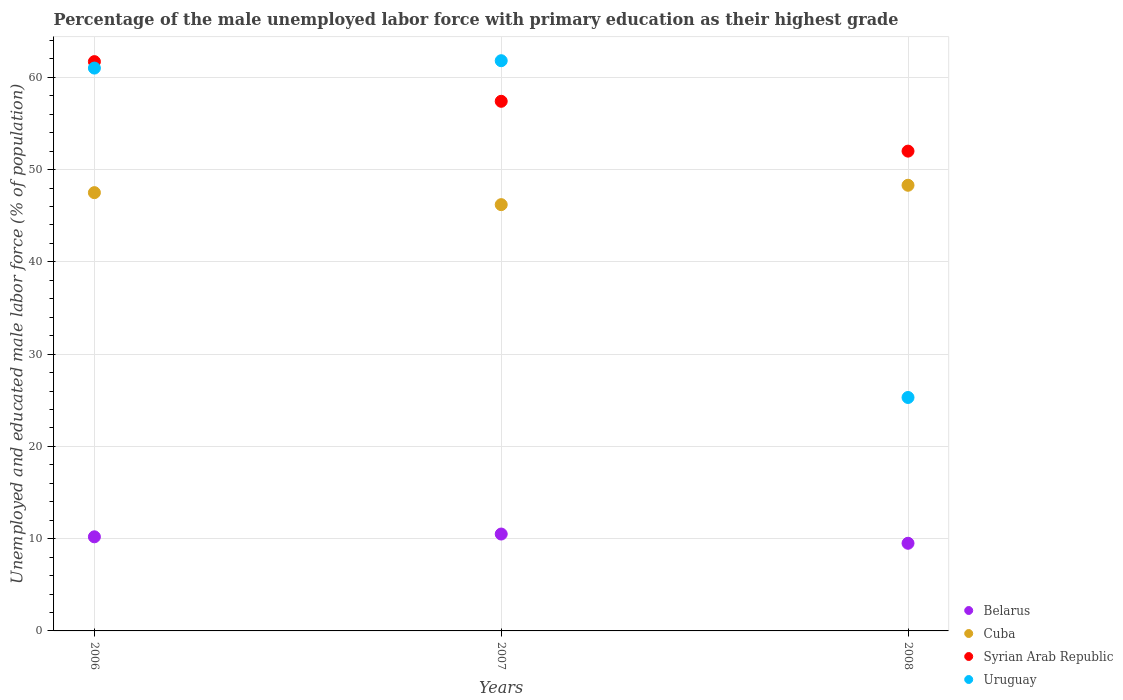How many different coloured dotlines are there?
Offer a terse response. 4. Is the number of dotlines equal to the number of legend labels?
Offer a terse response. Yes. What is the percentage of the unemployed male labor force with primary education in Cuba in 2008?
Keep it short and to the point. 48.3. Across all years, what is the maximum percentage of the unemployed male labor force with primary education in Belarus?
Make the answer very short. 10.5. Across all years, what is the minimum percentage of the unemployed male labor force with primary education in Cuba?
Offer a very short reply. 46.2. In which year was the percentage of the unemployed male labor force with primary education in Uruguay minimum?
Your response must be concise. 2008. What is the total percentage of the unemployed male labor force with primary education in Uruguay in the graph?
Offer a very short reply. 148.1. What is the difference between the percentage of the unemployed male labor force with primary education in Cuba in 2007 and that in 2008?
Make the answer very short. -2.1. What is the difference between the percentage of the unemployed male labor force with primary education in Cuba in 2008 and the percentage of the unemployed male labor force with primary education in Syrian Arab Republic in 2007?
Provide a succinct answer. -9.1. What is the average percentage of the unemployed male labor force with primary education in Belarus per year?
Offer a terse response. 10.07. In the year 2008, what is the difference between the percentage of the unemployed male labor force with primary education in Cuba and percentage of the unemployed male labor force with primary education in Uruguay?
Make the answer very short. 23. In how many years, is the percentage of the unemployed male labor force with primary education in Uruguay greater than 60 %?
Your answer should be compact. 2. What is the ratio of the percentage of the unemployed male labor force with primary education in Belarus in 2006 to that in 2008?
Your answer should be compact. 1.07. What is the difference between the highest and the second highest percentage of the unemployed male labor force with primary education in Uruguay?
Make the answer very short. 0.8. What is the difference between the highest and the lowest percentage of the unemployed male labor force with primary education in Cuba?
Your response must be concise. 2.1. In how many years, is the percentage of the unemployed male labor force with primary education in Belarus greater than the average percentage of the unemployed male labor force with primary education in Belarus taken over all years?
Provide a succinct answer. 2. Is the sum of the percentage of the unemployed male labor force with primary education in Belarus in 2006 and 2007 greater than the maximum percentage of the unemployed male labor force with primary education in Cuba across all years?
Keep it short and to the point. No. Does the percentage of the unemployed male labor force with primary education in Belarus monotonically increase over the years?
Ensure brevity in your answer.  No. Is the percentage of the unemployed male labor force with primary education in Uruguay strictly greater than the percentage of the unemployed male labor force with primary education in Cuba over the years?
Your answer should be compact. No. Is the percentage of the unemployed male labor force with primary education in Syrian Arab Republic strictly less than the percentage of the unemployed male labor force with primary education in Belarus over the years?
Give a very brief answer. No. How many dotlines are there?
Make the answer very short. 4. What is the difference between two consecutive major ticks on the Y-axis?
Make the answer very short. 10. Are the values on the major ticks of Y-axis written in scientific E-notation?
Your response must be concise. No. Does the graph contain any zero values?
Provide a succinct answer. No. Does the graph contain grids?
Give a very brief answer. Yes. Where does the legend appear in the graph?
Give a very brief answer. Bottom right. How are the legend labels stacked?
Ensure brevity in your answer.  Vertical. What is the title of the graph?
Offer a terse response. Percentage of the male unemployed labor force with primary education as their highest grade. Does "Turkey" appear as one of the legend labels in the graph?
Keep it short and to the point. No. What is the label or title of the Y-axis?
Give a very brief answer. Unemployed and educated male labor force (% of population). What is the Unemployed and educated male labor force (% of population) of Belarus in 2006?
Offer a very short reply. 10.2. What is the Unemployed and educated male labor force (% of population) of Cuba in 2006?
Your answer should be compact. 47.5. What is the Unemployed and educated male labor force (% of population) of Syrian Arab Republic in 2006?
Make the answer very short. 61.7. What is the Unemployed and educated male labor force (% of population) of Belarus in 2007?
Give a very brief answer. 10.5. What is the Unemployed and educated male labor force (% of population) of Cuba in 2007?
Ensure brevity in your answer.  46.2. What is the Unemployed and educated male labor force (% of population) of Syrian Arab Republic in 2007?
Keep it short and to the point. 57.4. What is the Unemployed and educated male labor force (% of population) of Uruguay in 2007?
Keep it short and to the point. 61.8. What is the Unemployed and educated male labor force (% of population) in Belarus in 2008?
Keep it short and to the point. 9.5. What is the Unemployed and educated male labor force (% of population) in Cuba in 2008?
Your response must be concise. 48.3. What is the Unemployed and educated male labor force (% of population) in Uruguay in 2008?
Offer a very short reply. 25.3. Across all years, what is the maximum Unemployed and educated male labor force (% of population) of Belarus?
Your answer should be compact. 10.5. Across all years, what is the maximum Unemployed and educated male labor force (% of population) of Cuba?
Make the answer very short. 48.3. Across all years, what is the maximum Unemployed and educated male labor force (% of population) in Syrian Arab Republic?
Make the answer very short. 61.7. Across all years, what is the maximum Unemployed and educated male labor force (% of population) in Uruguay?
Keep it short and to the point. 61.8. Across all years, what is the minimum Unemployed and educated male labor force (% of population) of Cuba?
Your response must be concise. 46.2. Across all years, what is the minimum Unemployed and educated male labor force (% of population) in Uruguay?
Your response must be concise. 25.3. What is the total Unemployed and educated male labor force (% of population) in Belarus in the graph?
Provide a short and direct response. 30.2. What is the total Unemployed and educated male labor force (% of population) in Cuba in the graph?
Offer a terse response. 142. What is the total Unemployed and educated male labor force (% of population) of Syrian Arab Republic in the graph?
Offer a very short reply. 171.1. What is the total Unemployed and educated male labor force (% of population) in Uruguay in the graph?
Your answer should be very brief. 148.1. What is the difference between the Unemployed and educated male labor force (% of population) of Syrian Arab Republic in 2006 and that in 2007?
Your response must be concise. 4.3. What is the difference between the Unemployed and educated male labor force (% of population) in Cuba in 2006 and that in 2008?
Provide a succinct answer. -0.8. What is the difference between the Unemployed and educated male labor force (% of population) of Uruguay in 2006 and that in 2008?
Provide a short and direct response. 35.7. What is the difference between the Unemployed and educated male labor force (% of population) in Cuba in 2007 and that in 2008?
Give a very brief answer. -2.1. What is the difference between the Unemployed and educated male labor force (% of population) of Syrian Arab Republic in 2007 and that in 2008?
Ensure brevity in your answer.  5.4. What is the difference between the Unemployed and educated male labor force (% of population) in Uruguay in 2007 and that in 2008?
Provide a succinct answer. 36.5. What is the difference between the Unemployed and educated male labor force (% of population) in Belarus in 2006 and the Unemployed and educated male labor force (% of population) in Cuba in 2007?
Your response must be concise. -36. What is the difference between the Unemployed and educated male labor force (% of population) in Belarus in 2006 and the Unemployed and educated male labor force (% of population) in Syrian Arab Republic in 2007?
Offer a terse response. -47.2. What is the difference between the Unemployed and educated male labor force (% of population) of Belarus in 2006 and the Unemployed and educated male labor force (% of population) of Uruguay in 2007?
Offer a very short reply. -51.6. What is the difference between the Unemployed and educated male labor force (% of population) of Cuba in 2006 and the Unemployed and educated male labor force (% of population) of Syrian Arab Republic in 2007?
Offer a very short reply. -9.9. What is the difference between the Unemployed and educated male labor force (% of population) in Cuba in 2006 and the Unemployed and educated male labor force (% of population) in Uruguay in 2007?
Your response must be concise. -14.3. What is the difference between the Unemployed and educated male labor force (% of population) of Syrian Arab Republic in 2006 and the Unemployed and educated male labor force (% of population) of Uruguay in 2007?
Provide a short and direct response. -0.1. What is the difference between the Unemployed and educated male labor force (% of population) of Belarus in 2006 and the Unemployed and educated male labor force (% of population) of Cuba in 2008?
Provide a succinct answer. -38.1. What is the difference between the Unemployed and educated male labor force (% of population) of Belarus in 2006 and the Unemployed and educated male labor force (% of population) of Syrian Arab Republic in 2008?
Give a very brief answer. -41.8. What is the difference between the Unemployed and educated male labor force (% of population) of Belarus in 2006 and the Unemployed and educated male labor force (% of population) of Uruguay in 2008?
Ensure brevity in your answer.  -15.1. What is the difference between the Unemployed and educated male labor force (% of population) of Syrian Arab Republic in 2006 and the Unemployed and educated male labor force (% of population) of Uruguay in 2008?
Your response must be concise. 36.4. What is the difference between the Unemployed and educated male labor force (% of population) of Belarus in 2007 and the Unemployed and educated male labor force (% of population) of Cuba in 2008?
Offer a very short reply. -37.8. What is the difference between the Unemployed and educated male labor force (% of population) in Belarus in 2007 and the Unemployed and educated male labor force (% of population) in Syrian Arab Republic in 2008?
Your answer should be very brief. -41.5. What is the difference between the Unemployed and educated male labor force (% of population) in Belarus in 2007 and the Unemployed and educated male labor force (% of population) in Uruguay in 2008?
Your response must be concise. -14.8. What is the difference between the Unemployed and educated male labor force (% of population) in Cuba in 2007 and the Unemployed and educated male labor force (% of population) in Syrian Arab Republic in 2008?
Your answer should be very brief. -5.8. What is the difference between the Unemployed and educated male labor force (% of population) in Cuba in 2007 and the Unemployed and educated male labor force (% of population) in Uruguay in 2008?
Make the answer very short. 20.9. What is the difference between the Unemployed and educated male labor force (% of population) in Syrian Arab Republic in 2007 and the Unemployed and educated male labor force (% of population) in Uruguay in 2008?
Make the answer very short. 32.1. What is the average Unemployed and educated male labor force (% of population) in Belarus per year?
Give a very brief answer. 10.07. What is the average Unemployed and educated male labor force (% of population) of Cuba per year?
Your answer should be compact. 47.33. What is the average Unemployed and educated male labor force (% of population) in Syrian Arab Republic per year?
Make the answer very short. 57.03. What is the average Unemployed and educated male labor force (% of population) in Uruguay per year?
Ensure brevity in your answer.  49.37. In the year 2006, what is the difference between the Unemployed and educated male labor force (% of population) of Belarus and Unemployed and educated male labor force (% of population) of Cuba?
Give a very brief answer. -37.3. In the year 2006, what is the difference between the Unemployed and educated male labor force (% of population) in Belarus and Unemployed and educated male labor force (% of population) in Syrian Arab Republic?
Give a very brief answer. -51.5. In the year 2006, what is the difference between the Unemployed and educated male labor force (% of population) of Belarus and Unemployed and educated male labor force (% of population) of Uruguay?
Give a very brief answer. -50.8. In the year 2006, what is the difference between the Unemployed and educated male labor force (% of population) in Cuba and Unemployed and educated male labor force (% of population) in Uruguay?
Offer a very short reply. -13.5. In the year 2006, what is the difference between the Unemployed and educated male labor force (% of population) in Syrian Arab Republic and Unemployed and educated male labor force (% of population) in Uruguay?
Offer a very short reply. 0.7. In the year 2007, what is the difference between the Unemployed and educated male labor force (% of population) in Belarus and Unemployed and educated male labor force (% of population) in Cuba?
Provide a succinct answer. -35.7. In the year 2007, what is the difference between the Unemployed and educated male labor force (% of population) in Belarus and Unemployed and educated male labor force (% of population) in Syrian Arab Republic?
Offer a terse response. -46.9. In the year 2007, what is the difference between the Unemployed and educated male labor force (% of population) of Belarus and Unemployed and educated male labor force (% of population) of Uruguay?
Provide a short and direct response. -51.3. In the year 2007, what is the difference between the Unemployed and educated male labor force (% of population) in Cuba and Unemployed and educated male labor force (% of population) in Syrian Arab Republic?
Your answer should be compact. -11.2. In the year 2007, what is the difference between the Unemployed and educated male labor force (% of population) in Cuba and Unemployed and educated male labor force (% of population) in Uruguay?
Ensure brevity in your answer.  -15.6. In the year 2008, what is the difference between the Unemployed and educated male labor force (% of population) in Belarus and Unemployed and educated male labor force (% of population) in Cuba?
Give a very brief answer. -38.8. In the year 2008, what is the difference between the Unemployed and educated male labor force (% of population) in Belarus and Unemployed and educated male labor force (% of population) in Syrian Arab Republic?
Provide a short and direct response. -42.5. In the year 2008, what is the difference between the Unemployed and educated male labor force (% of population) of Belarus and Unemployed and educated male labor force (% of population) of Uruguay?
Offer a terse response. -15.8. In the year 2008, what is the difference between the Unemployed and educated male labor force (% of population) of Cuba and Unemployed and educated male labor force (% of population) of Syrian Arab Republic?
Your answer should be very brief. -3.7. In the year 2008, what is the difference between the Unemployed and educated male labor force (% of population) of Syrian Arab Republic and Unemployed and educated male labor force (% of population) of Uruguay?
Offer a terse response. 26.7. What is the ratio of the Unemployed and educated male labor force (% of population) of Belarus in 2006 to that in 2007?
Your answer should be compact. 0.97. What is the ratio of the Unemployed and educated male labor force (% of population) in Cuba in 2006 to that in 2007?
Make the answer very short. 1.03. What is the ratio of the Unemployed and educated male labor force (% of population) in Syrian Arab Republic in 2006 to that in 2007?
Offer a very short reply. 1.07. What is the ratio of the Unemployed and educated male labor force (% of population) of Uruguay in 2006 to that in 2007?
Provide a succinct answer. 0.99. What is the ratio of the Unemployed and educated male labor force (% of population) in Belarus in 2006 to that in 2008?
Your answer should be compact. 1.07. What is the ratio of the Unemployed and educated male labor force (% of population) of Cuba in 2006 to that in 2008?
Your answer should be very brief. 0.98. What is the ratio of the Unemployed and educated male labor force (% of population) in Syrian Arab Republic in 2006 to that in 2008?
Your answer should be very brief. 1.19. What is the ratio of the Unemployed and educated male labor force (% of population) of Uruguay in 2006 to that in 2008?
Make the answer very short. 2.41. What is the ratio of the Unemployed and educated male labor force (% of population) of Belarus in 2007 to that in 2008?
Your response must be concise. 1.11. What is the ratio of the Unemployed and educated male labor force (% of population) of Cuba in 2007 to that in 2008?
Offer a terse response. 0.96. What is the ratio of the Unemployed and educated male labor force (% of population) of Syrian Arab Republic in 2007 to that in 2008?
Offer a terse response. 1.1. What is the ratio of the Unemployed and educated male labor force (% of population) of Uruguay in 2007 to that in 2008?
Your response must be concise. 2.44. What is the difference between the highest and the second highest Unemployed and educated male labor force (% of population) in Belarus?
Your answer should be compact. 0.3. What is the difference between the highest and the second highest Unemployed and educated male labor force (% of population) of Cuba?
Provide a short and direct response. 0.8. What is the difference between the highest and the second highest Unemployed and educated male labor force (% of population) in Syrian Arab Republic?
Your response must be concise. 4.3. What is the difference between the highest and the lowest Unemployed and educated male labor force (% of population) in Belarus?
Offer a very short reply. 1. What is the difference between the highest and the lowest Unemployed and educated male labor force (% of population) of Cuba?
Provide a short and direct response. 2.1. What is the difference between the highest and the lowest Unemployed and educated male labor force (% of population) of Syrian Arab Republic?
Your response must be concise. 9.7. What is the difference between the highest and the lowest Unemployed and educated male labor force (% of population) of Uruguay?
Offer a very short reply. 36.5. 